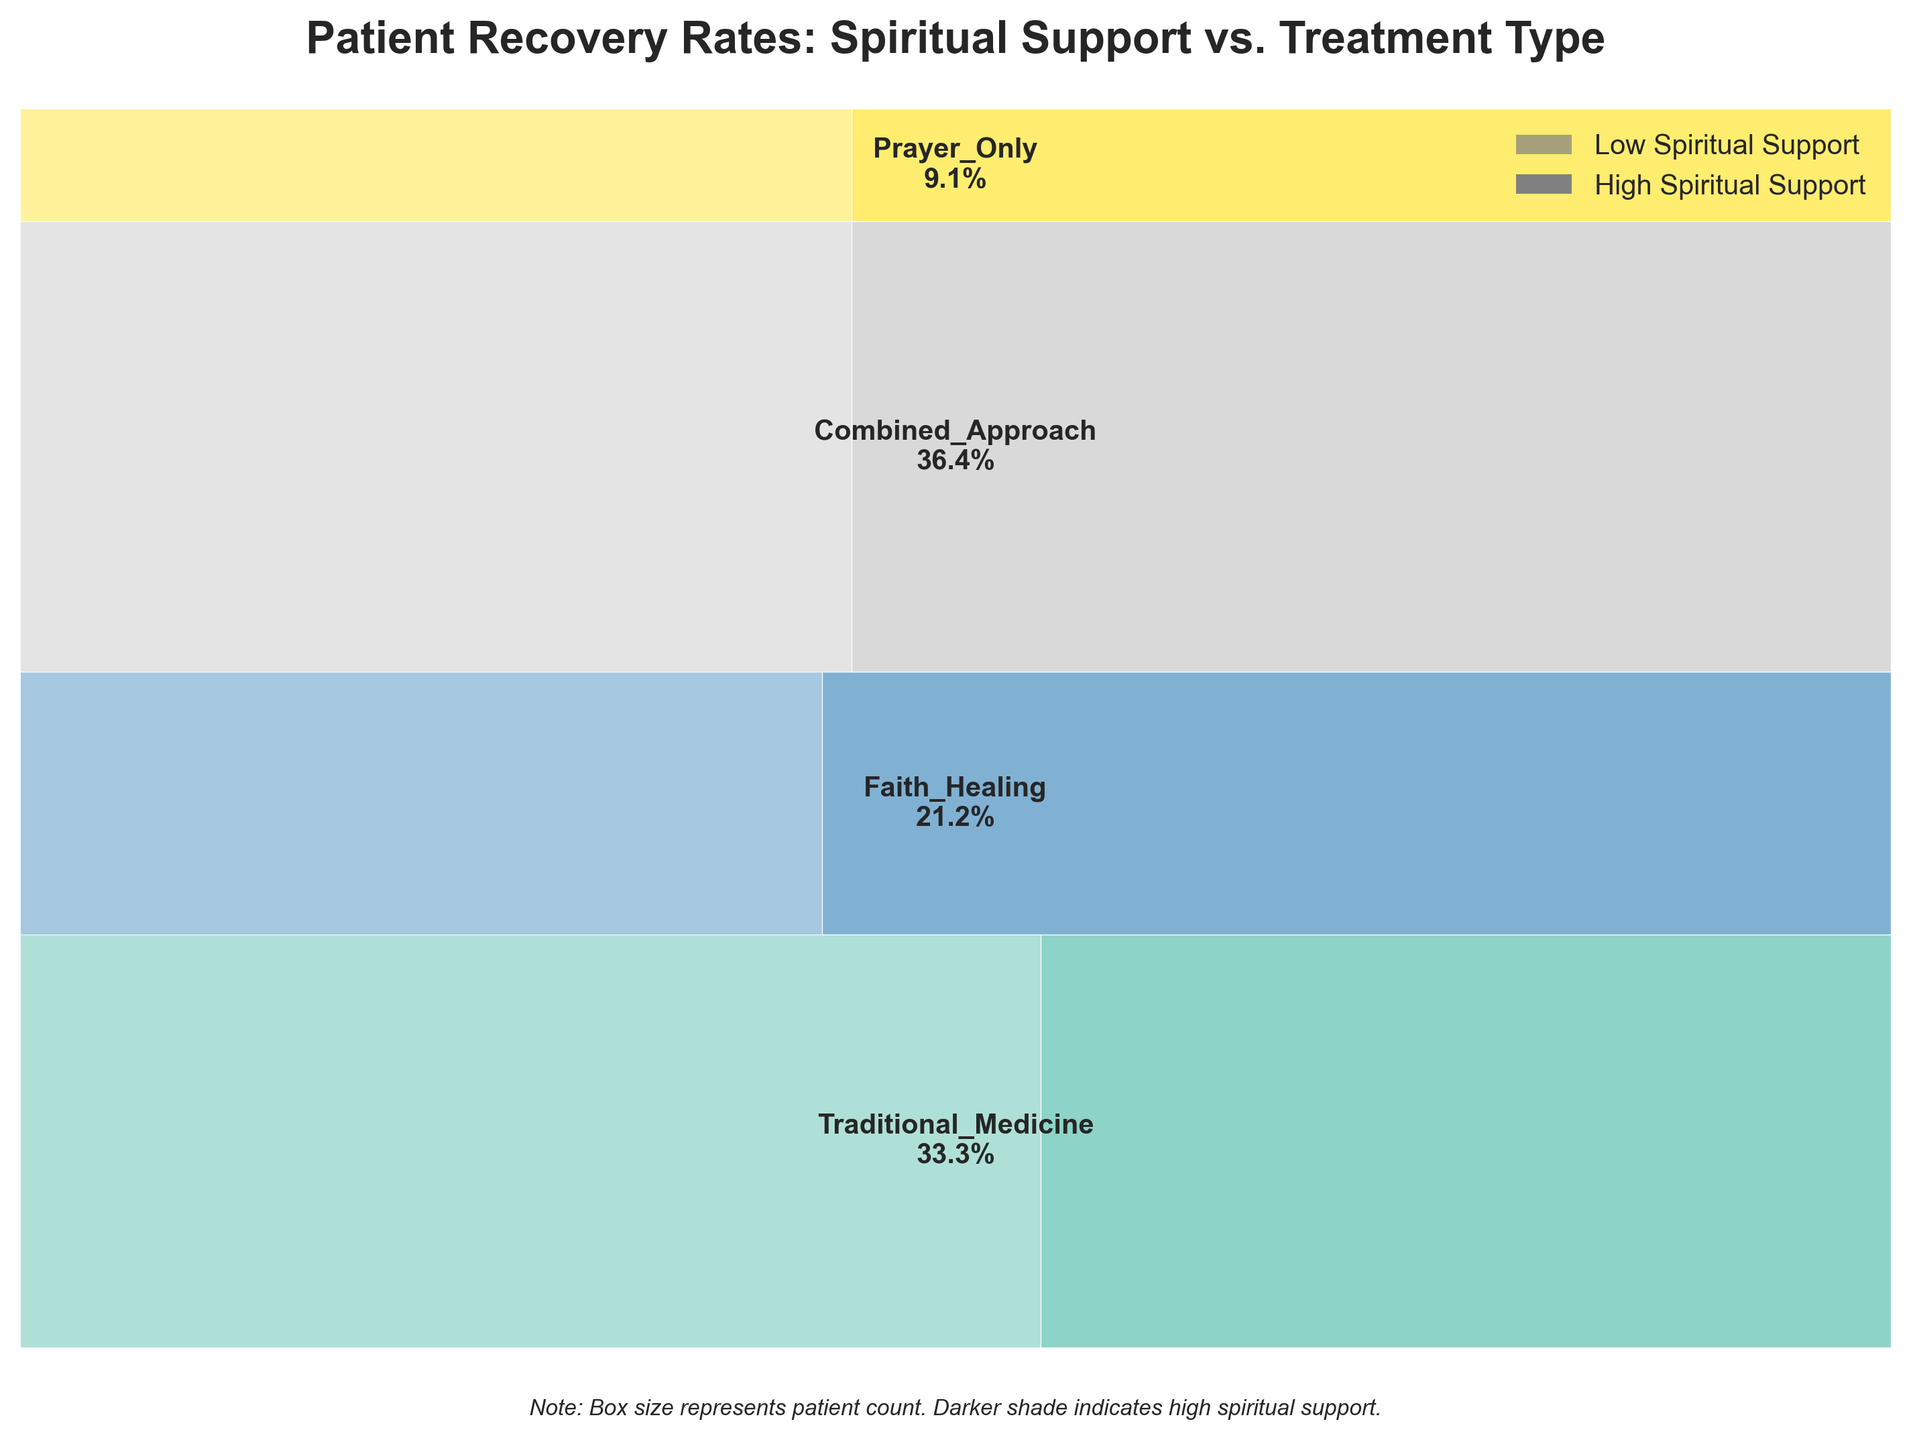What's the title of the figure? The title is usually placed at the top of the figure in bold. You can find it easily by looking at the center-top of the image. Here, it reads "Patient Recovery Rates: Spiritual Support vs. Treatment Type."
Answer: Patient Recovery Rates: Spiritual Support vs. Treatment Type How many different types of treatments are shown in the figure? Treatments are represented by different colored sections stacked vertically on the plot. By counting these sections, you can determine the number of unique treatments. There are five: Traditional Medicine, Faith Healing, Combined Approach, Prayer Only, and another unnamed.
Answer: Five Which treatment has the highest proportion of high spiritual support? High spiritual support is shown with a darker shade. Look for the section with the largest dark area proportionally. The "Combined Approach" has the largest section of dark shading.
Answer: Combined Approach Which treatment shows the lowest recovery rate with high spiritual support? Recovery rates within spiritual support levels are given by darker shaded sections. Compare the figures for high spiritual support; "Prayer Only" has the lowest recovery rate with a value of 45%.
Answer: Prayer Only Which treatment has the highest overall recovery rate? The overall recovery rates are indicated within each treatment section. By comparing these percentages, the "Combined Approach" (92%) has the highest recovery rate.
Answer: Combined Approach How does the recovery rate of Traditional Medicine with low spiritual support compare to that with high spiritual support? First identify the rates for Traditional Medicine: low support (78%) and high support (85%). Calculate the difference 85% - 78%.
Answer: 7% higher Which treatment has the highest number of patients with high spiritual support? The patient count is proportional to the size of the boxes. The "Combined Approach" section with dark shading is the largest, indicating the highest count with 200 patients.
Answer: Combined Approach What's the total number of patients for the Faith Healing treatment? Faith Healing has 120 patients with high spiritual support and 90 with low, summed to 120 + 90 = 210.
Answer: 210 Describe the relative proportions of high to low spiritual support in the "Combined Approach" treatment. In the "Combined Approach" section, the area indicates the patient count. High spiritual support (darker) is larger than low (lighter). Thus, the high support has a larger proportion.
Answer: High > Low What insight does this plot give about the effect of combined traditional and faith-based healing compared to either approach alone? Compare recovery rates and patient counts: "Combined Approach" has both the highest recovery rate and the most patients, suggesting better outcomes when combining both types.
Answer: More effective than either alone 